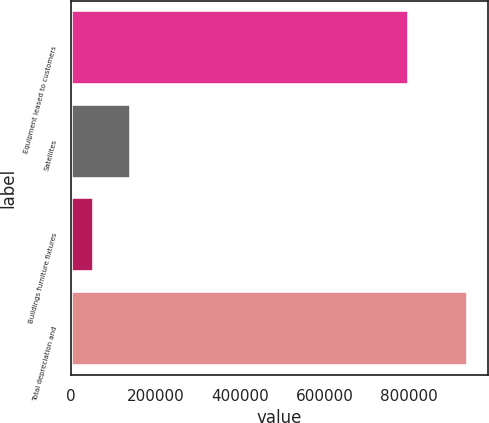<chart> <loc_0><loc_0><loc_500><loc_500><bar_chart><fcel>Equipment leased to customers<fcel>Satellites<fcel>Buildings furniture fixtures<fcel>Total depreciation and<nl><fcel>799169<fcel>142994<fcel>54434<fcel>940033<nl></chart> 